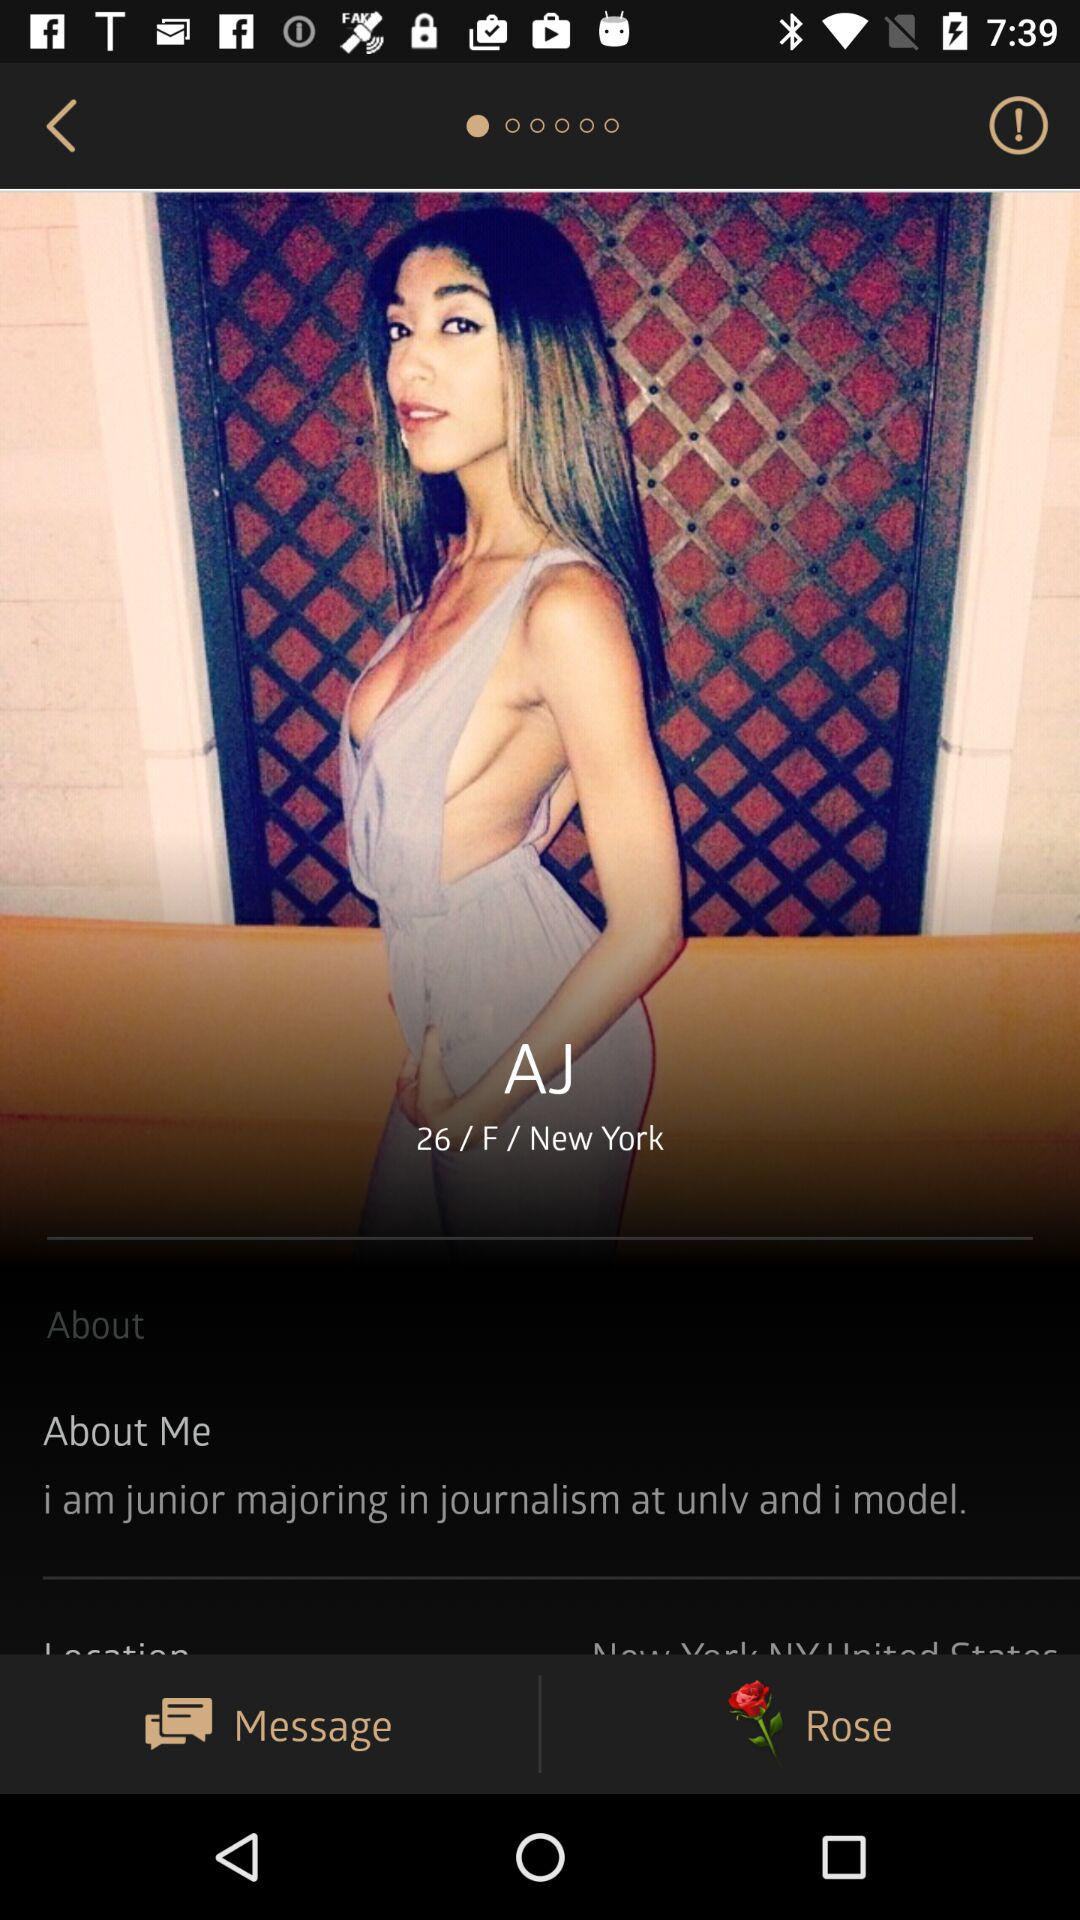Where does AJ live? AJ lives in "New York". 